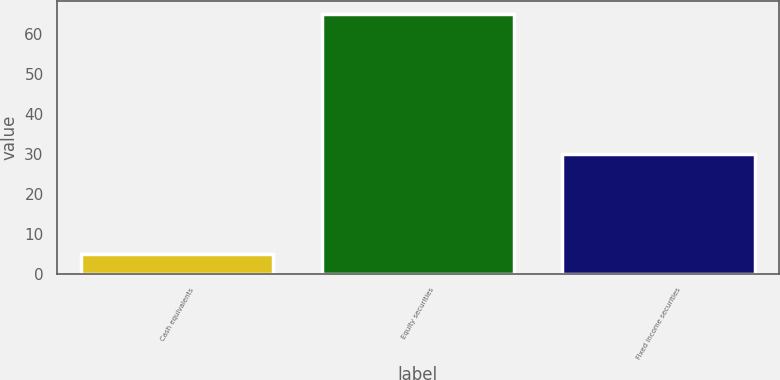Convert chart to OTSL. <chart><loc_0><loc_0><loc_500><loc_500><bar_chart><fcel>Cash equivalents<fcel>Equity securities<fcel>Fixed income securities<nl><fcel>5<fcel>65<fcel>30<nl></chart> 